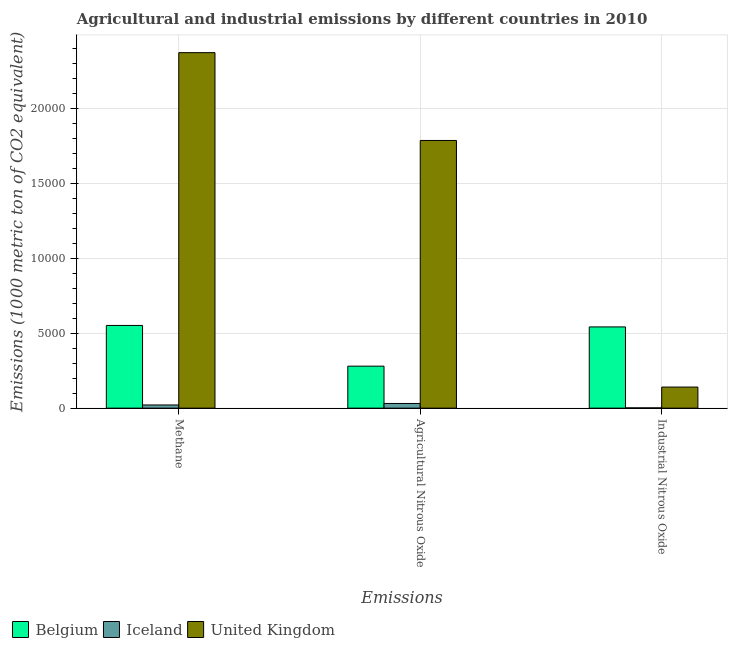Are the number of bars per tick equal to the number of legend labels?
Your response must be concise. Yes. How many bars are there on the 2nd tick from the left?
Your response must be concise. 3. What is the label of the 3rd group of bars from the left?
Give a very brief answer. Industrial Nitrous Oxide. What is the amount of industrial nitrous oxide emissions in Belgium?
Provide a short and direct response. 5417.1. Across all countries, what is the maximum amount of methane emissions?
Provide a succinct answer. 2.37e+04. Across all countries, what is the minimum amount of agricultural nitrous oxide emissions?
Offer a terse response. 311.8. In which country was the amount of methane emissions minimum?
Offer a very short reply. Iceland. What is the total amount of industrial nitrous oxide emissions in the graph?
Offer a terse response. 6841.4. What is the difference between the amount of methane emissions in Iceland and that in United Kingdom?
Your answer should be very brief. -2.35e+04. What is the difference between the amount of methane emissions in Belgium and the amount of industrial nitrous oxide emissions in United Kingdom?
Your answer should be compact. 4109. What is the average amount of agricultural nitrous oxide emissions per country?
Provide a succinct answer. 6988.23. What is the difference between the amount of industrial nitrous oxide emissions and amount of agricultural nitrous oxide emissions in United Kingdom?
Your answer should be compact. -1.64e+04. What is the ratio of the amount of industrial nitrous oxide emissions in Iceland to that in Belgium?
Keep it short and to the point. 0. What is the difference between the highest and the second highest amount of methane emissions?
Offer a terse response. 1.82e+04. What is the difference between the highest and the lowest amount of agricultural nitrous oxide emissions?
Give a very brief answer. 1.75e+04. What does the 2nd bar from the left in Agricultural Nitrous Oxide represents?
Your answer should be very brief. Iceland. What does the 1st bar from the right in Agricultural Nitrous Oxide represents?
Make the answer very short. United Kingdom. Is it the case that in every country, the sum of the amount of methane emissions and amount of agricultural nitrous oxide emissions is greater than the amount of industrial nitrous oxide emissions?
Offer a terse response. Yes. How many bars are there?
Give a very brief answer. 9. Are the values on the major ticks of Y-axis written in scientific E-notation?
Your response must be concise. No. How are the legend labels stacked?
Keep it short and to the point. Horizontal. What is the title of the graph?
Offer a very short reply. Agricultural and industrial emissions by different countries in 2010. Does "Bolivia" appear as one of the legend labels in the graph?
Your response must be concise. No. What is the label or title of the X-axis?
Your answer should be very brief. Emissions. What is the label or title of the Y-axis?
Ensure brevity in your answer.  Emissions (1000 metric ton of CO2 equivalent). What is the Emissions (1000 metric ton of CO2 equivalent) of Belgium in Methane?
Ensure brevity in your answer.  5515.6. What is the Emissions (1000 metric ton of CO2 equivalent) in Iceland in Methane?
Offer a terse response. 212.4. What is the Emissions (1000 metric ton of CO2 equivalent) of United Kingdom in Methane?
Your response must be concise. 2.37e+04. What is the Emissions (1000 metric ton of CO2 equivalent) of Belgium in Agricultural Nitrous Oxide?
Your answer should be very brief. 2801.2. What is the Emissions (1000 metric ton of CO2 equivalent) of Iceland in Agricultural Nitrous Oxide?
Keep it short and to the point. 311.8. What is the Emissions (1000 metric ton of CO2 equivalent) of United Kingdom in Agricultural Nitrous Oxide?
Your answer should be very brief. 1.79e+04. What is the Emissions (1000 metric ton of CO2 equivalent) in Belgium in Industrial Nitrous Oxide?
Offer a very short reply. 5417.1. What is the Emissions (1000 metric ton of CO2 equivalent) in United Kingdom in Industrial Nitrous Oxide?
Provide a short and direct response. 1406.6. Across all Emissions, what is the maximum Emissions (1000 metric ton of CO2 equivalent) in Belgium?
Give a very brief answer. 5515.6. Across all Emissions, what is the maximum Emissions (1000 metric ton of CO2 equivalent) of Iceland?
Provide a succinct answer. 311.8. Across all Emissions, what is the maximum Emissions (1000 metric ton of CO2 equivalent) in United Kingdom?
Provide a short and direct response. 2.37e+04. Across all Emissions, what is the minimum Emissions (1000 metric ton of CO2 equivalent) of Belgium?
Provide a short and direct response. 2801.2. Across all Emissions, what is the minimum Emissions (1000 metric ton of CO2 equivalent) in Iceland?
Your answer should be very brief. 17.7. Across all Emissions, what is the minimum Emissions (1000 metric ton of CO2 equivalent) in United Kingdom?
Offer a very short reply. 1406.6. What is the total Emissions (1000 metric ton of CO2 equivalent) in Belgium in the graph?
Provide a succinct answer. 1.37e+04. What is the total Emissions (1000 metric ton of CO2 equivalent) in Iceland in the graph?
Provide a succinct answer. 541.9. What is the total Emissions (1000 metric ton of CO2 equivalent) in United Kingdom in the graph?
Your response must be concise. 4.30e+04. What is the difference between the Emissions (1000 metric ton of CO2 equivalent) of Belgium in Methane and that in Agricultural Nitrous Oxide?
Keep it short and to the point. 2714.4. What is the difference between the Emissions (1000 metric ton of CO2 equivalent) in Iceland in Methane and that in Agricultural Nitrous Oxide?
Your answer should be compact. -99.4. What is the difference between the Emissions (1000 metric ton of CO2 equivalent) in United Kingdom in Methane and that in Agricultural Nitrous Oxide?
Your answer should be compact. 5856.1. What is the difference between the Emissions (1000 metric ton of CO2 equivalent) in Belgium in Methane and that in Industrial Nitrous Oxide?
Ensure brevity in your answer.  98.5. What is the difference between the Emissions (1000 metric ton of CO2 equivalent) in Iceland in Methane and that in Industrial Nitrous Oxide?
Your response must be concise. 194.7. What is the difference between the Emissions (1000 metric ton of CO2 equivalent) of United Kingdom in Methane and that in Industrial Nitrous Oxide?
Provide a short and direct response. 2.23e+04. What is the difference between the Emissions (1000 metric ton of CO2 equivalent) in Belgium in Agricultural Nitrous Oxide and that in Industrial Nitrous Oxide?
Provide a short and direct response. -2615.9. What is the difference between the Emissions (1000 metric ton of CO2 equivalent) in Iceland in Agricultural Nitrous Oxide and that in Industrial Nitrous Oxide?
Ensure brevity in your answer.  294.1. What is the difference between the Emissions (1000 metric ton of CO2 equivalent) in United Kingdom in Agricultural Nitrous Oxide and that in Industrial Nitrous Oxide?
Ensure brevity in your answer.  1.64e+04. What is the difference between the Emissions (1000 metric ton of CO2 equivalent) of Belgium in Methane and the Emissions (1000 metric ton of CO2 equivalent) of Iceland in Agricultural Nitrous Oxide?
Your response must be concise. 5203.8. What is the difference between the Emissions (1000 metric ton of CO2 equivalent) of Belgium in Methane and the Emissions (1000 metric ton of CO2 equivalent) of United Kingdom in Agricultural Nitrous Oxide?
Offer a very short reply. -1.23e+04. What is the difference between the Emissions (1000 metric ton of CO2 equivalent) in Iceland in Methane and the Emissions (1000 metric ton of CO2 equivalent) in United Kingdom in Agricultural Nitrous Oxide?
Keep it short and to the point. -1.76e+04. What is the difference between the Emissions (1000 metric ton of CO2 equivalent) of Belgium in Methane and the Emissions (1000 metric ton of CO2 equivalent) of Iceland in Industrial Nitrous Oxide?
Make the answer very short. 5497.9. What is the difference between the Emissions (1000 metric ton of CO2 equivalent) of Belgium in Methane and the Emissions (1000 metric ton of CO2 equivalent) of United Kingdom in Industrial Nitrous Oxide?
Give a very brief answer. 4109. What is the difference between the Emissions (1000 metric ton of CO2 equivalent) in Iceland in Methane and the Emissions (1000 metric ton of CO2 equivalent) in United Kingdom in Industrial Nitrous Oxide?
Keep it short and to the point. -1194.2. What is the difference between the Emissions (1000 metric ton of CO2 equivalent) of Belgium in Agricultural Nitrous Oxide and the Emissions (1000 metric ton of CO2 equivalent) of Iceland in Industrial Nitrous Oxide?
Your response must be concise. 2783.5. What is the difference between the Emissions (1000 metric ton of CO2 equivalent) of Belgium in Agricultural Nitrous Oxide and the Emissions (1000 metric ton of CO2 equivalent) of United Kingdom in Industrial Nitrous Oxide?
Your answer should be compact. 1394.6. What is the difference between the Emissions (1000 metric ton of CO2 equivalent) in Iceland in Agricultural Nitrous Oxide and the Emissions (1000 metric ton of CO2 equivalent) in United Kingdom in Industrial Nitrous Oxide?
Offer a very short reply. -1094.8. What is the average Emissions (1000 metric ton of CO2 equivalent) in Belgium per Emissions?
Your answer should be compact. 4577.97. What is the average Emissions (1000 metric ton of CO2 equivalent) in Iceland per Emissions?
Give a very brief answer. 180.63. What is the average Emissions (1000 metric ton of CO2 equivalent) in United Kingdom per Emissions?
Your answer should be compact. 1.43e+04. What is the difference between the Emissions (1000 metric ton of CO2 equivalent) in Belgium and Emissions (1000 metric ton of CO2 equivalent) in Iceland in Methane?
Give a very brief answer. 5303.2. What is the difference between the Emissions (1000 metric ton of CO2 equivalent) of Belgium and Emissions (1000 metric ton of CO2 equivalent) of United Kingdom in Methane?
Give a very brief answer. -1.82e+04. What is the difference between the Emissions (1000 metric ton of CO2 equivalent) of Iceland and Emissions (1000 metric ton of CO2 equivalent) of United Kingdom in Methane?
Give a very brief answer. -2.35e+04. What is the difference between the Emissions (1000 metric ton of CO2 equivalent) in Belgium and Emissions (1000 metric ton of CO2 equivalent) in Iceland in Agricultural Nitrous Oxide?
Make the answer very short. 2489.4. What is the difference between the Emissions (1000 metric ton of CO2 equivalent) of Belgium and Emissions (1000 metric ton of CO2 equivalent) of United Kingdom in Agricultural Nitrous Oxide?
Keep it short and to the point. -1.51e+04. What is the difference between the Emissions (1000 metric ton of CO2 equivalent) of Iceland and Emissions (1000 metric ton of CO2 equivalent) of United Kingdom in Agricultural Nitrous Oxide?
Your answer should be very brief. -1.75e+04. What is the difference between the Emissions (1000 metric ton of CO2 equivalent) in Belgium and Emissions (1000 metric ton of CO2 equivalent) in Iceland in Industrial Nitrous Oxide?
Your response must be concise. 5399.4. What is the difference between the Emissions (1000 metric ton of CO2 equivalent) in Belgium and Emissions (1000 metric ton of CO2 equivalent) in United Kingdom in Industrial Nitrous Oxide?
Provide a short and direct response. 4010.5. What is the difference between the Emissions (1000 metric ton of CO2 equivalent) in Iceland and Emissions (1000 metric ton of CO2 equivalent) in United Kingdom in Industrial Nitrous Oxide?
Provide a short and direct response. -1388.9. What is the ratio of the Emissions (1000 metric ton of CO2 equivalent) of Belgium in Methane to that in Agricultural Nitrous Oxide?
Give a very brief answer. 1.97. What is the ratio of the Emissions (1000 metric ton of CO2 equivalent) in Iceland in Methane to that in Agricultural Nitrous Oxide?
Your answer should be compact. 0.68. What is the ratio of the Emissions (1000 metric ton of CO2 equivalent) of United Kingdom in Methane to that in Agricultural Nitrous Oxide?
Offer a terse response. 1.33. What is the ratio of the Emissions (1000 metric ton of CO2 equivalent) in Belgium in Methane to that in Industrial Nitrous Oxide?
Keep it short and to the point. 1.02. What is the ratio of the Emissions (1000 metric ton of CO2 equivalent) in Iceland in Methane to that in Industrial Nitrous Oxide?
Your answer should be very brief. 12. What is the ratio of the Emissions (1000 metric ton of CO2 equivalent) of United Kingdom in Methane to that in Industrial Nitrous Oxide?
Offer a very short reply. 16.85. What is the ratio of the Emissions (1000 metric ton of CO2 equivalent) of Belgium in Agricultural Nitrous Oxide to that in Industrial Nitrous Oxide?
Offer a terse response. 0.52. What is the ratio of the Emissions (1000 metric ton of CO2 equivalent) in Iceland in Agricultural Nitrous Oxide to that in Industrial Nitrous Oxide?
Keep it short and to the point. 17.62. What is the ratio of the Emissions (1000 metric ton of CO2 equivalent) of United Kingdom in Agricultural Nitrous Oxide to that in Industrial Nitrous Oxide?
Offer a very short reply. 12.69. What is the difference between the highest and the second highest Emissions (1000 metric ton of CO2 equivalent) in Belgium?
Make the answer very short. 98.5. What is the difference between the highest and the second highest Emissions (1000 metric ton of CO2 equivalent) of Iceland?
Offer a very short reply. 99.4. What is the difference between the highest and the second highest Emissions (1000 metric ton of CO2 equivalent) in United Kingdom?
Provide a succinct answer. 5856.1. What is the difference between the highest and the lowest Emissions (1000 metric ton of CO2 equivalent) in Belgium?
Make the answer very short. 2714.4. What is the difference between the highest and the lowest Emissions (1000 metric ton of CO2 equivalent) in Iceland?
Make the answer very short. 294.1. What is the difference between the highest and the lowest Emissions (1000 metric ton of CO2 equivalent) in United Kingdom?
Provide a short and direct response. 2.23e+04. 